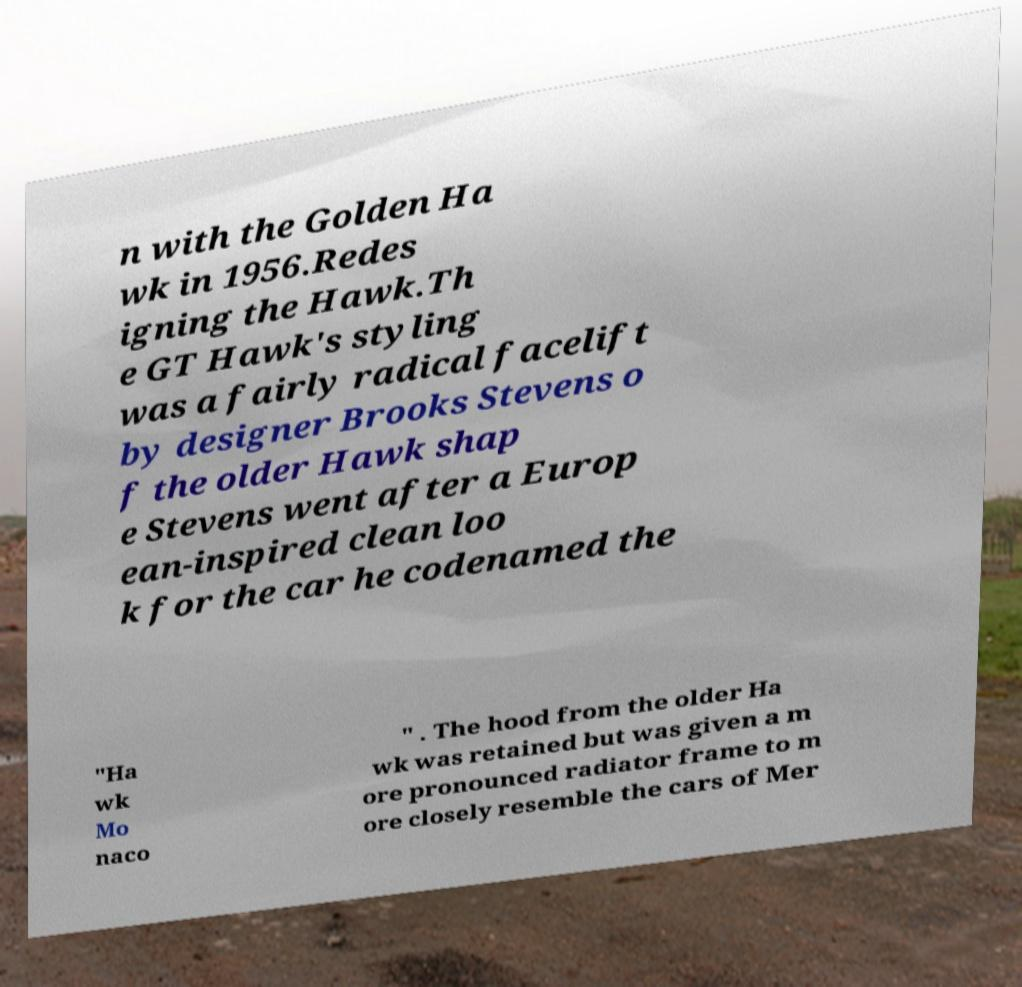Can you read and provide the text displayed in the image?This photo seems to have some interesting text. Can you extract and type it out for me? n with the Golden Ha wk in 1956.Redes igning the Hawk.Th e GT Hawk's styling was a fairly radical facelift by designer Brooks Stevens o f the older Hawk shap e Stevens went after a Europ ean-inspired clean loo k for the car he codenamed the "Ha wk Mo naco " . The hood from the older Ha wk was retained but was given a m ore pronounced radiator frame to m ore closely resemble the cars of Mer 